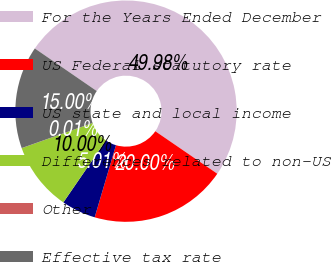Convert chart. <chart><loc_0><loc_0><loc_500><loc_500><pie_chart><fcel>For the Years Ended December<fcel>US Federal statutory rate<fcel>US state and local income<fcel>Differences related to non-US<fcel>Other<fcel>Effective tax rate<nl><fcel>49.98%<fcel>20.0%<fcel>5.01%<fcel>10.0%<fcel>0.01%<fcel>15.0%<nl></chart> 